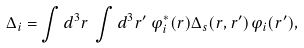Convert formula to latex. <formula><loc_0><loc_0><loc_500><loc_500>\Delta _ { i } = \int d ^ { 3 } r \, \int d ^ { 3 } r ^ { \prime } \, \varphi _ { i } ^ { \ast } ( { r } ) \Delta _ { s } ( { r } , { r ^ { \prime } } ) \varphi _ { i } ( { r ^ { \prime } } ) ,</formula> 